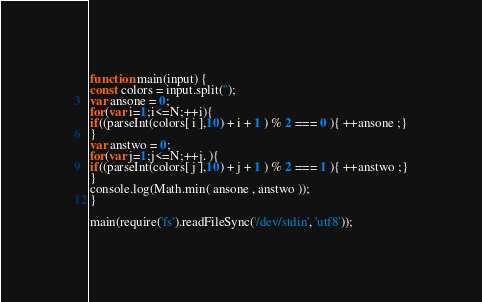<code> <loc_0><loc_0><loc_500><loc_500><_JavaScript_>function main(input) {
const colors = input.split('');
var ansone = 0;
for(var i=1;i<=N;++i){
if((parseInt(colors[ i ],10) + i + 1 ) % 2 === 0 ){ ++ansone ;}
}
var anstwo = 0;
for(var j=1;j<=N;++j. ){
if((parseInt(colors[ j ],10) + j + 1 ) % 2 === 1 ){ ++anstwo ;}
}
console.log(Math.min( ansone , anstwo ));
}

main(require('fs').readFileSync('/dev/stdin', 'utf8'));
</code> 